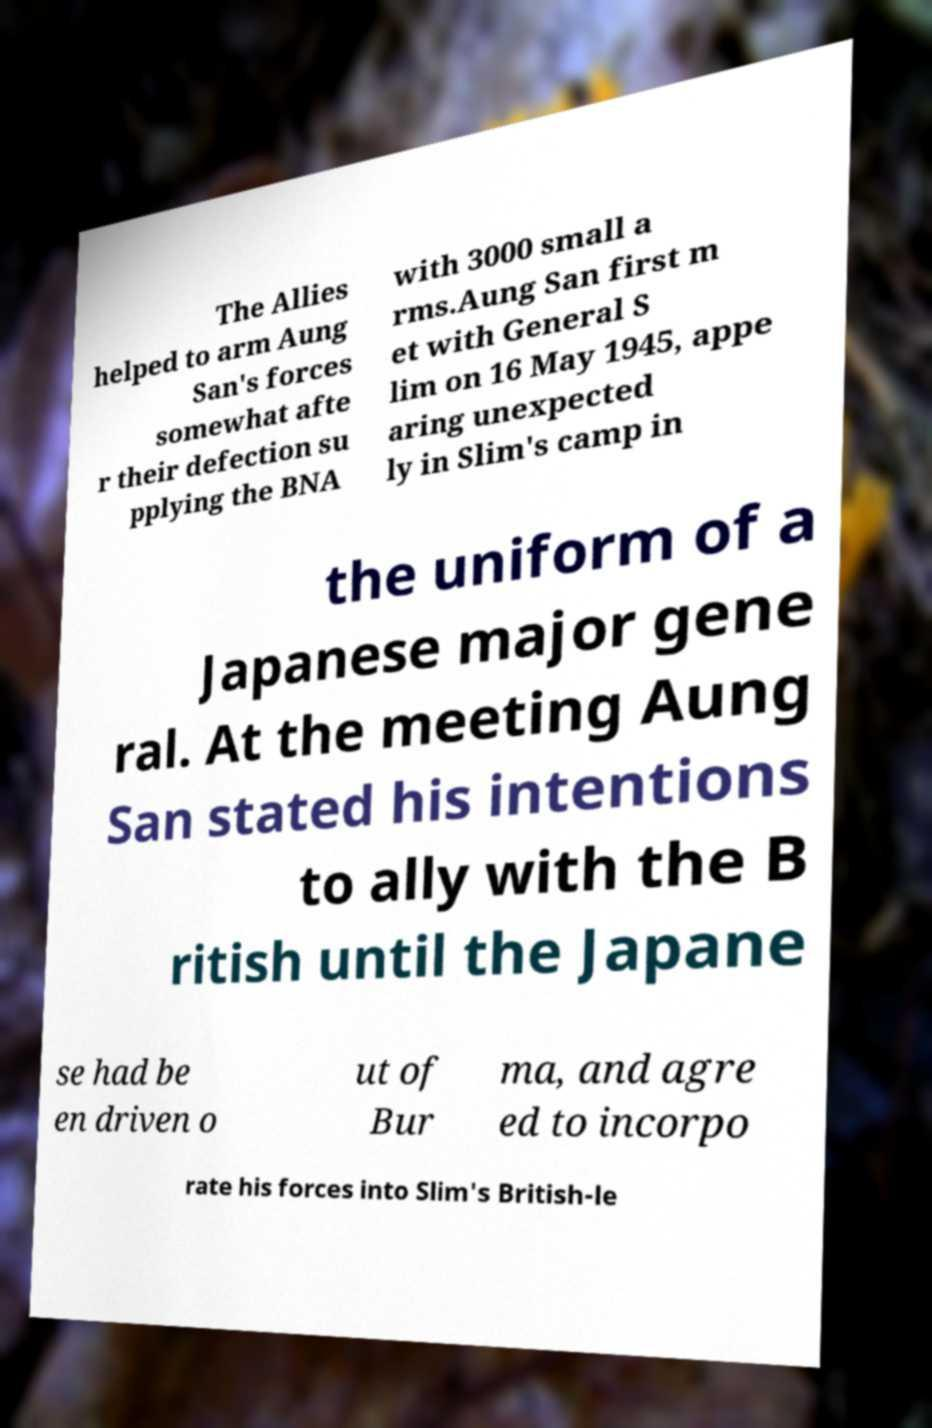Could you extract and type out the text from this image? The Allies helped to arm Aung San's forces somewhat afte r their defection su pplying the BNA with 3000 small a rms.Aung San first m et with General S lim on 16 May 1945, appe aring unexpected ly in Slim's camp in the uniform of a Japanese major gene ral. At the meeting Aung San stated his intentions to ally with the B ritish until the Japane se had be en driven o ut of Bur ma, and agre ed to incorpo rate his forces into Slim's British-le 